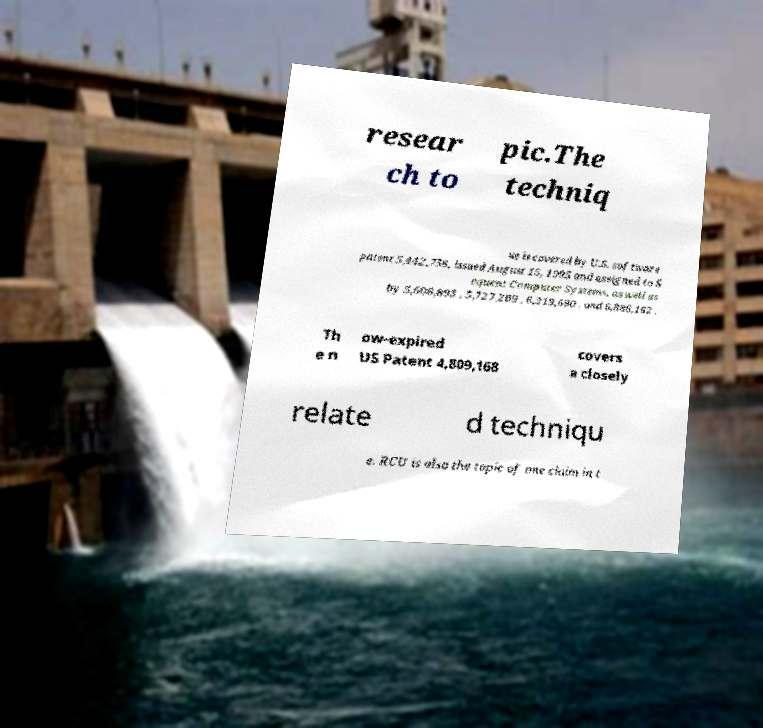Could you assist in decoding the text presented in this image and type it out clearly? resear ch to pic.The techniq ue is covered by U.S. software patent 5,442,758, issued August 15, 1995 and assigned to S equent Computer Systems, as well as by 5,608,893 , 5,727,209 , 6,219,690 , and 6,886,162 . Th e n ow-expired US Patent 4,809,168 covers a closely relate d techniqu e. RCU is also the topic of one claim in t 